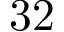Convert formula to latex. <formula><loc_0><loc_0><loc_500><loc_500>3 2</formula> 